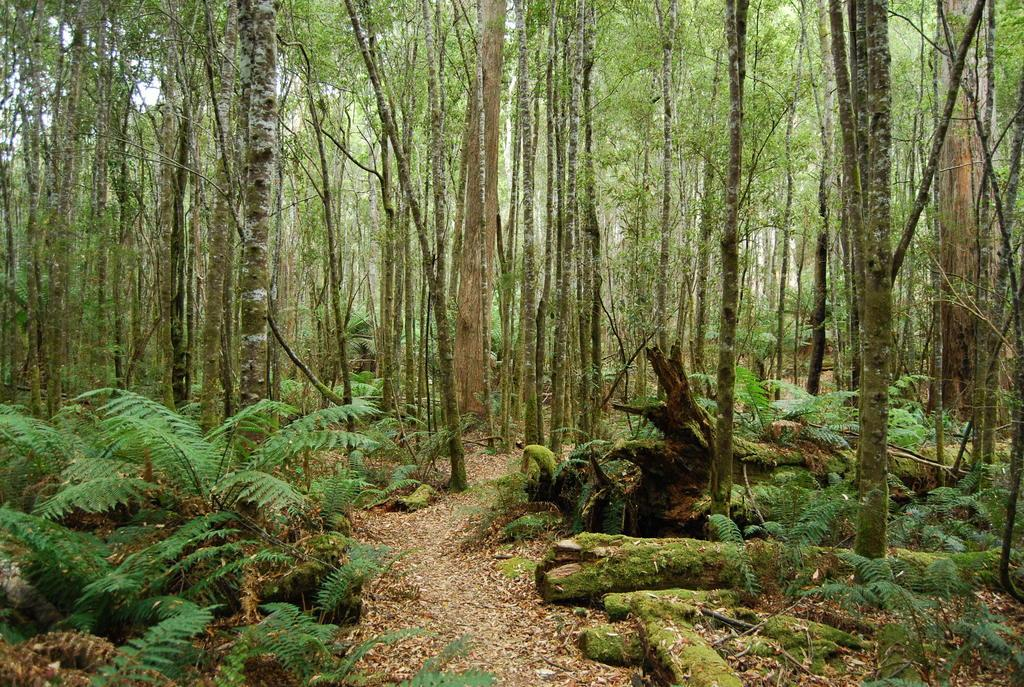What type of vegetation can be seen in the image? There are trees and plants in the image. What other objects can be seen in the image? There are wooden logs and dry leaves visible in the image. Is there any indication of a path or trail in the image? Yes, there is a path visible in the image. How many chickens are present in the image? There are no chickens present in the image. What type of brush can be seen in the image? There is no brush present in the image. 